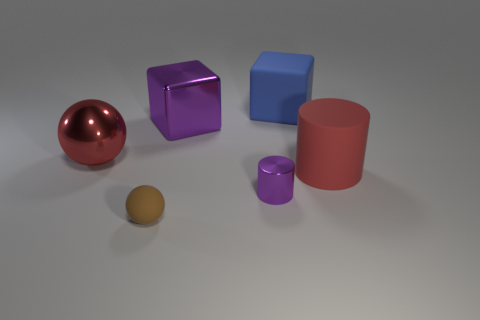Is there a tiny cylinder to the left of the big rubber thing that is behind the red object on the right side of the brown matte thing?
Ensure brevity in your answer.  Yes. The cylinder that is the same color as the shiny sphere is what size?
Your answer should be compact. Large. Are there any tiny cylinders behind the large matte cylinder?
Offer a very short reply. No. What number of other things are the same shape as the brown matte thing?
Your answer should be compact. 1. What color is the cylinder that is the same size as the red metallic ball?
Offer a terse response. Red. Is the number of large purple metallic blocks right of the red cylinder less than the number of large red spheres in front of the large sphere?
Give a very brief answer. No. There is a large red object that is on the right side of the rubber object that is behind the big rubber cylinder; what number of small balls are to the right of it?
Offer a terse response. 0. There is a matte object that is the same shape as the large red metal object; what is its size?
Make the answer very short. Small. Are there any other things that are the same size as the brown object?
Your answer should be very brief. Yes. Is the number of tiny metallic objects in front of the small brown thing less than the number of metal cylinders?
Your answer should be compact. Yes. 